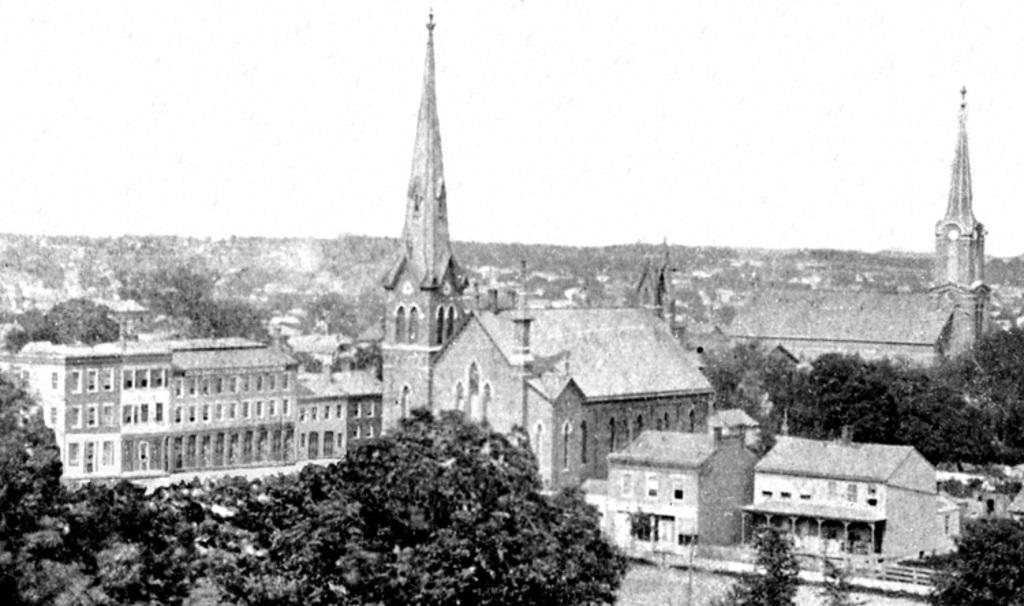What type of structures can be seen in the image? There are buildings in the image. What other natural elements are present in the image? There are trees in the image. Where are the buildings and trees located in the image? The buildings and trees are located in the center of the image. Can you see any giants playing volleyball near the river in the image? There is no river, volleyball, or giants present in the image; it only features buildings and trees. 